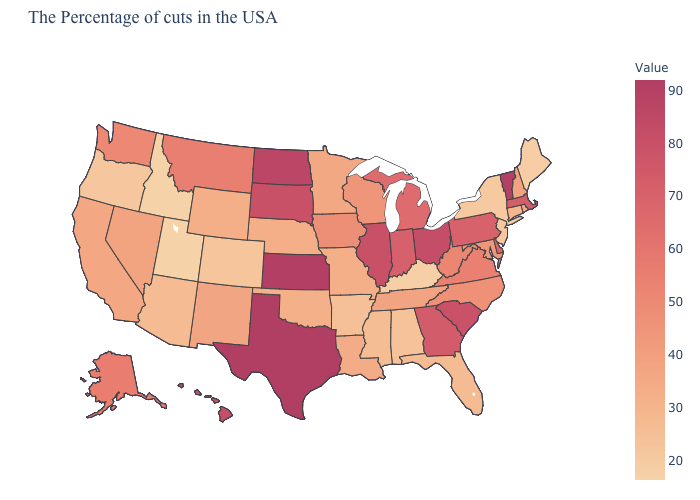Which states have the lowest value in the USA?
Give a very brief answer. Idaho. Does Nebraska have the lowest value in the MidWest?
Short answer required. Yes. Among the states that border Kansas , does Colorado have the highest value?
Give a very brief answer. No. Among the states that border Florida , which have the highest value?
Be succinct. Georgia. Among the states that border Minnesota , which have the highest value?
Be succinct. North Dakota. 